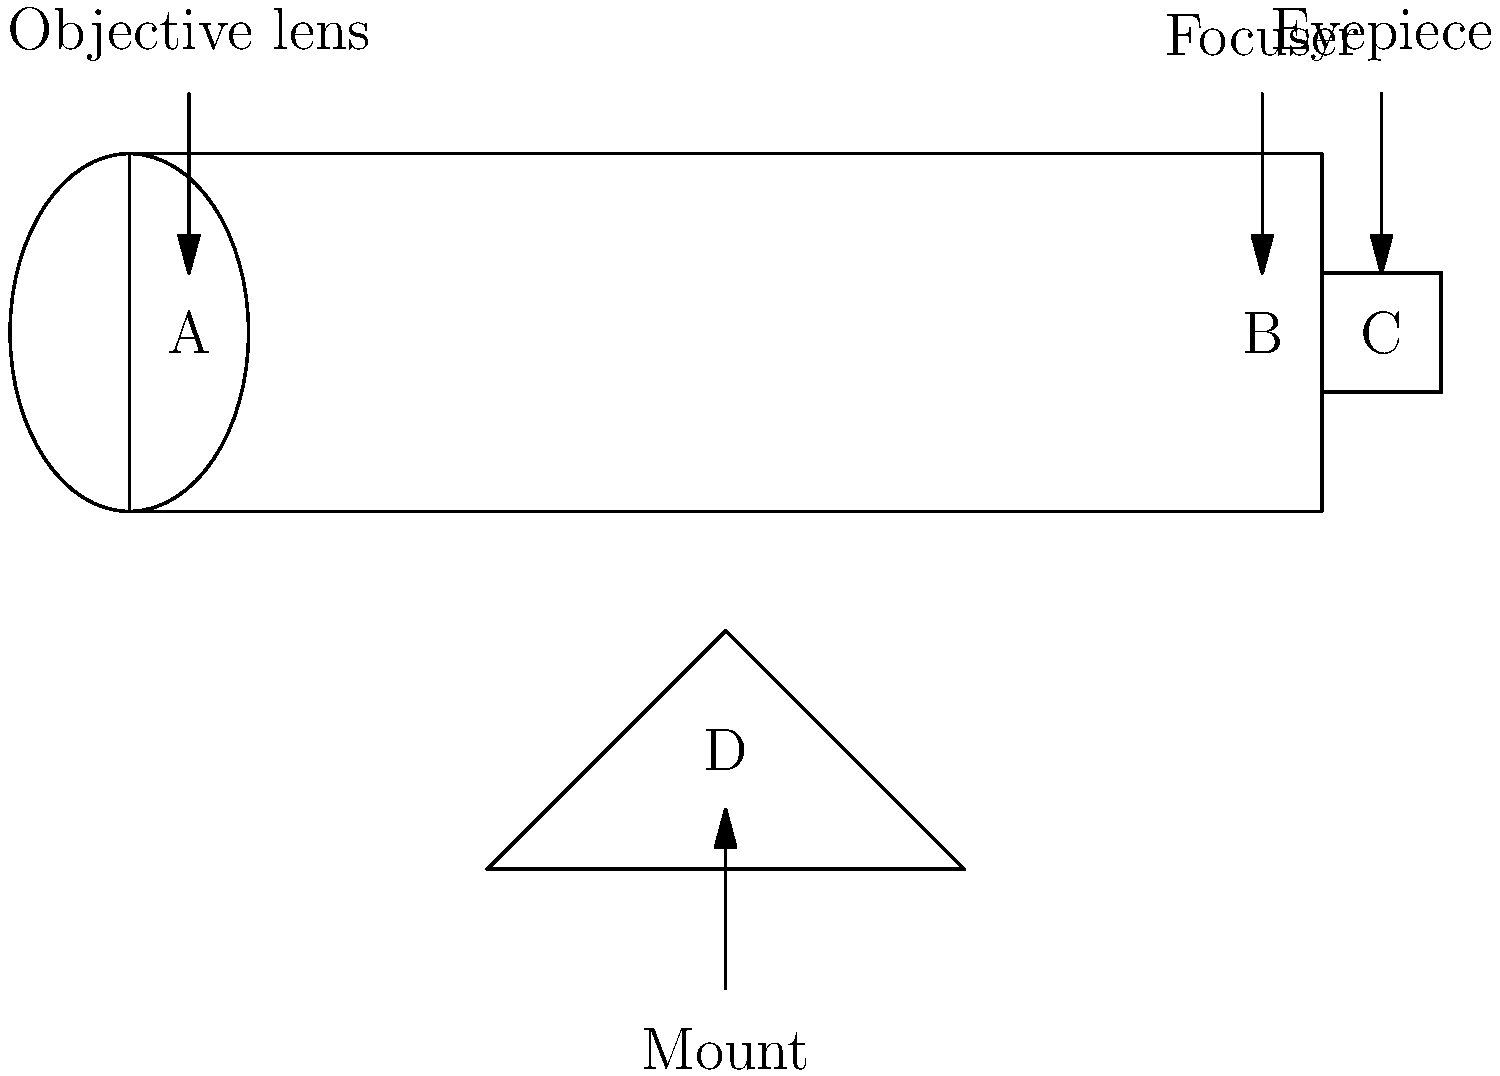As a wildlife conservationist with a keen eye for detail, you're setting up a stargazing event for endangered nocturnal species. You need to explain the parts of a telescope to your team. Which component, labeled in the diagram, is responsible for gathering and focusing light from distant celestial objects? Let's break down the main components of the telescope shown in the diagram:

1. Part A: This is the objective lens, located at the front of the telescope. It's the largest lens in the telescope and is crucial for its function.

2. Part B: This represents the focuser, which allows for fine adjustments to achieve a clear image.

3. Part C: This is the eyepiece, where the observer looks through to see the magnified image.

4. Part D: This is the mount, which supports the telescope and allows for positioning.

The component responsible for gathering and focusing light from distant celestial objects is the objective lens (Part A). Here's why:

1. Light gathering: The objective lens has a large surface area to collect as much light as possible from faint, distant objects.

2. Primary focus: It focuses the collected light to form an image inside the telescope tube.

3. Magnification: The size of the objective lens determines the telescope's light-gathering power and resolution capability.

4. First point of contact: It's the first optical element that incoming light encounters, making it crucial for the telescope's performance.

The other parts, while important, serve different functions:
- The focuser (B) adjusts the position of the eyepiece to sharpen the image.
- The eyepiece (C) further magnifies the image formed by the objective lens.
- The mount (D) provides stability and allows for tracking celestial objects.
Answer: Objective lens (A) 